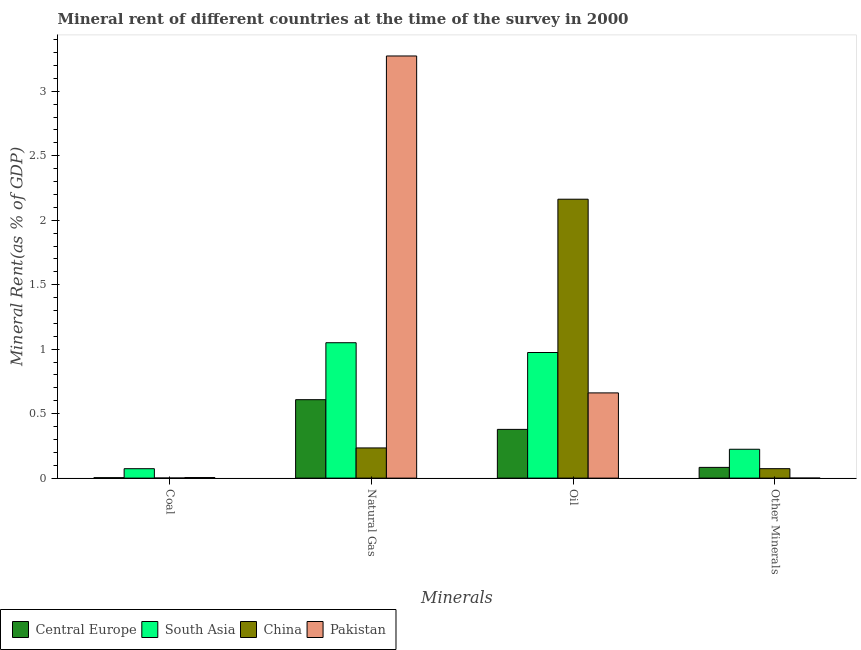How many different coloured bars are there?
Ensure brevity in your answer.  4. Are the number of bars on each tick of the X-axis equal?
Offer a very short reply. Yes. What is the label of the 4th group of bars from the left?
Give a very brief answer. Other Minerals. What is the natural gas rent in Pakistan?
Make the answer very short. 3.27. Across all countries, what is the maximum  rent of other minerals?
Keep it short and to the point. 0.22. Across all countries, what is the minimum coal rent?
Provide a succinct answer. 0. In which country was the natural gas rent maximum?
Your answer should be very brief. Pakistan. In which country was the  rent of other minerals minimum?
Provide a succinct answer. Pakistan. What is the total coal rent in the graph?
Provide a short and direct response. 0.08. What is the difference between the coal rent in China and that in Pakistan?
Ensure brevity in your answer.  -0. What is the difference between the oil rent in Central Europe and the natural gas rent in China?
Provide a succinct answer. 0.14. What is the average oil rent per country?
Provide a succinct answer. 1.04. What is the difference between the oil rent and  rent of other minerals in South Asia?
Offer a terse response. 0.75. What is the ratio of the oil rent in Pakistan to that in China?
Your response must be concise. 0.31. Is the difference between the coal rent in Central Europe and China greater than the difference between the oil rent in Central Europe and China?
Make the answer very short. Yes. What is the difference between the highest and the second highest  rent of other minerals?
Provide a short and direct response. 0.14. What is the difference between the highest and the lowest natural gas rent?
Ensure brevity in your answer.  3.04. Is it the case that in every country, the sum of the natural gas rent and coal rent is greater than the sum of oil rent and  rent of other minerals?
Your answer should be very brief. No. What does the 1st bar from the right in Coal represents?
Offer a very short reply. Pakistan. How many bars are there?
Ensure brevity in your answer.  16. Does the graph contain any zero values?
Provide a succinct answer. No. How many legend labels are there?
Offer a very short reply. 4. What is the title of the graph?
Provide a short and direct response. Mineral rent of different countries at the time of the survey in 2000. Does "Tajikistan" appear as one of the legend labels in the graph?
Ensure brevity in your answer.  No. What is the label or title of the X-axis?
Your answer should be compact. Minerals. What is the label or title of the Y-axis?
Keep it short and to the point. Mineral Rent(as % of GDP). What is the Mineral Rent(as % of GDP) in Central Europe in Coal?
Offer a very short reply. 0. What is the Mineral Rent(as % of GDP) of South Asia in Coal?
Provide a succinct answer. 0.07. What is the Mineral Rent(as % of GDP) in China in Coal?
Your answer should be compact. 0. What is the Mineral Rent(as % of GDP) of Pakistan in Coal?
Your answer should be compact. 0. What is the Mineral Rent(as % of GDP) in Central Europe in Natural Gas?
Offer a terse response. 0.61. What is the Mineral Rent(as % of GDP) of South Asia in Natural Gas?
Give a very brief answer. 1.05. What is the Mineral Rent(as % of GDP) in China in Natural Gas?
Your response must be concise. 0.23. What is the Mineral Rent(as % of GDP) of Pakistan in Natural Gas?
Make the answer very short. 3.27. What is the Mineral Rent(as % of GDP) of Central Europe in Oil?
Your response must be concise. 0.38. What is the Mineral Rent(as % of GDP) in South Asia in Oil?
Provide a short and direct response. 0.97. What is the Mineral Rent(as % of GDP) of China in Oil?
Ensure brevity in your answer.  2.16. What is the Mineral Rent(as % of GDP) in Pakistan in Oil?
Make the answer very short. 0.66. What is the Mineral Rent(as % of GDP) in Central Europe in Other Minerals?
Offer a very short reply. 0.08. What is the Mineral Rent(as % of GDP) in South Asia in Other Minerals?
Make the answer very short. 0.22. What is the Mineral Rent(as % of GDP) in China in Other Minerals?
Provide a succinct answer. 0.07. What is the Mineral Rent(as % of GDP) of Pakistan in Other Minerals?
Your answer should be very brief. 0. Across all Minerals, what is the maximum Mineral Rent(as % of GDP) in Central Europe?
Make the answer very short. 0.61. Across all Minerals, what is the maximum Mineral Rent(as % of GDP) in South Asia?
Your answer should be very brief. 1.05. Across all Minerals, what is the maximum Mineral Rent(as % of GDP) in China?
Keep it short and to the point. 2.16. Across all Minerals, what is the maximum Mineral Rent(as % of GDP) in Pakistan?
Offer a terse response. 3.27. Across all Minerals, what is the minimum Mineral Rent(as % of GDP) in Central Europe?
Offer a very short reply. 0. Across all Minerals, what is the minimum Mineral Rent(as % of GDP) of South Asia?
Keep it short and to the point. 0.07. Across all Minerals, what is the minimum Mineral Rent(as % of GDP) in China?
Your answer should be very brief. 0. Across all Minerals, what is the minimum Mineral Rent(as % of GDP) of Pakistan?
Offer a terse response. 0. What is the total Mineral Rent(as % of GDP) of Central Europe in the graph?
Make the answer very short. 1.07. What is the total Mineral Rent(as % of GDP) of South Asia in the graph?
Keep it short and to the point. 2.32. What is the total Mineral Rent(as % of GDP) in China in the graph?
Provide a succinct answer. 2.47. What is the total Mineral Rent(as % of GDP) in Pakistan in the graph?
Ensure brevity in your answer.  3.94. What is the difference between the Mineral Rent(as % of GDP) of Central Europe in Coal and that in Natural Gas?
Provide a short and direct response. -0.6. What is the difference between the Mineral Rent(as % of GDP) in South Asia in Coal and that in Natural Gas?
Ensure brevity in your answer.  -0.98. What is the difference between the Mineral Rent(as % of GDP) in China in Coal and that in Natural Gas?
Ensure brevity in your answer.  -0.23. What is the difference between the Mineral Rent(as % of GDP) in Pakistan in Coal and that in Natural Gas?
Keep it short and to the point. -3.27. What is the difference between the Mineral Rent(as % of GDP) of Central Europe in Coal and that in Oil?
Offer a very short reply. -0.37. What is the difference between the Mineral Rent(as % of GDP) of South Asia in Coal and that in Oil?
Give a very brief answer. -0.9. What is the difference between the Mineral Rent(as % of GDP) in China in Coal and that in Oil?
Provide a short and direct response. -2.16. What is the difference between the Mineral Rent(as % of GDP) in Pakistan in Coal and that in Oil?
Keep it short and to the point. -0.66. What is the difference between the Mineral Rent(as % of GDP) of Central Europe in Coal and that in Other Minerals?
Offer a very short reply. -0.08. What is the difference between the Mineral Rent(as % of GDP) in South Asia in Coal and that in Other Minerals?
Offer a very short reply. -0.15. What is the difference between the Mineral Rent(as % of GDP) in China in Coal and that in Other Minerals?
Offer a very short reply. -0.07. What is the difference between the Mineral Rent(as % of GDP) of Pakistan in Coal and that in Other Minerals?
Your answer should be very brief. 0. What is the difference between the Mineral Rent(as % of GDP) in Central Europe in Natural Gas and that in Oil?
Give a very brief answer. 0.23. What is the difference between the Mineral Rent(as % of GDP) in South Asia in Natural Gas and that in Oil?
Ensure brevity in your answer.  0.08. What is the difference between the Mineral Rent(as % of GDP) of China in Natural Gas and that in Oil?
Give a very brief answer. -1.93. What is the difference between the Mineral Rent(as % of GDP) in Pakistan in Natural Gas and that in Oil?
Provide a short and direct response. 2.61. What is the difference between the Mineral Rent(as % of GDP) of Central Europe in Natural Gas and that in Other Minerals?
Your response must be concise. 0.53. What is the difference between the Mineral Rent(as % of GDP) in South Asia in Natural Gas and that in Other Minerals?
Offer a terse response. 0.83. What is the difference between the Mineral Rent(as % of GDP) in China in Natural Gas and that in Other Minerals?
Your response must be concise. 0.16. What is the difference between the Mineral Rent(as % of GDP) of Pakistan in Natural Gas and that in Other Minerals?
Keep it short and to the point. 3.27. What is the difference between the Mineral Rent(as % of GDP) of Central Europe in Oil and that in Other Minerals?
Your answer should be compact. 0.29. What is the difference between the Mineral Rent(as % of GDP) in South Asia in Oil and that in Other Minerals?
Your response must be concise. 0.75. What is the difference between the Mineral Rent(as % of GDP) of China in Oil and that in Other Minerals?
Offer a terse response. 2.09. What is the difference between the Mineral Rent(as % of GDP) in Pakistan in Oil and that in Other Minerals?
Provide a short and direct response. 0.66. What is the difference between the Mineral Rent(as % of GDP) of Central Europe in Coal and the Mineral Rent(as % of GDP) of South Asia in Natural Gas?
Your answer should be compact. -1.05. What is the difference between the Mineral Rent(as % of GDP) of Central Europe in Coal and the Mineral Rent(as % of GDP) of China in Natural Gas?
Keep it short and to the point. -0.23. What is the difference between the Mineral Rent(as % of GDP) of Central Europe in Coal and the Mineral Rent(as % of GDP) of Pakistan in Natural Gas?
Your answer should be very brief. -3.27. What is the difference between the Mineral Rent(as % of GDP) in South Asia in Coal and the Mineral Rent(as % of GDP) in China in Natural Gas?
Offer a terse response. -0.16. What is the difference between the Mineral Rent(as % of GDP) of South Asia in Coal and the Mineral Rent(as % of GDP) of Pakistan in Natural Gas?
Provide a short and direct response. -3.2. What is the difference between the Mineral Rent(as % of GDP) of China in Coal and the Mineral Rent(as % of GDP) of Pakistan in Natural Gas?
Make the answer very short. -3.27. What is the difference between the Mineral Rent(as % of GDP) of Central Europe in Coal and the Mineral Rent(as % of GDP) of South Asia in Oil?
Your response must be concise. -0.97. What is the difference between the Mineral Rent(as % of GDP) in Central Europe in Coal and the Mineral Rent(as % of GDP) in China in Oil?
Your response must be concise. -2.16. What is the difference between the Mineral Rent(as % of GDP) in Central Europe in Coal and the Mineral Rent(as % of GDP) in Pakistan in Oil?
Keep it short and to the point. -0.66. What is the difference between the Mineral Rent(as % of GDP) of South Asia in Coal and the Mineral Rent(as % of GDP) of China in Oil?
Offer a terse response. -2.09. What is the difference between the Mineral Rent(as % of GDP) of South Asia in Coal and the Mineral Rent(as % of GDP) of Pakistan in Oil?
Your answer should be compact. -0.59. What is the difference between the Mineral Rent(as % of GDP) in China in Coal and the Mineral Rent(as % of GDP) in Pakistan in Oil?
Keep it short and to the point. -0.66. What is the difference between the Mineral Rent(as % of GDP) in Central Europe in Coal and the Mineral Rent(as % of GDP) in South Asia in Other Minerals?
Give a very brief answer. -0.22. What is the difference between the Mineral Rent(as % of GDP) of Central Europe in Coal and the Mineral Rent(as % of GDP) of China in Other Minerals?
Make the answer very short. -0.07. What is the difference between the Mineral Rent(as % of GDP) of Central Europe in Coal and the Mineral Rent(as % of GDP) of Pakistan in Other Minerals?
Offer a terse response. 0. What is the difference between the Mineral Rent(as % of GDP) of South Asia in Coal and the Mineral Rent(as % of GDP) of China in Other Minerals?
Your response must be concise. -0. What is the difference between the Mineral Rent(as % of GDP) in South Asia in Coal and the Mineral Rent(as % of GDP) in Pakistan in Other Minerals?
Your response must be concise. 0.07. What is the difference between the Mineral Rent(as % of GDP) of China in Coal and the Mineral Rent(as % of GDP) of Pakistan in Other Minerals?
Your response must be concise. 0. What is the difference between the Mineral Rent(as % of GDP) of Central Europe in Natural Gas and the Mineral Rent(as % of GDP) of South Asia in Oil?
Provide a succinct answer. -0.37. What is the difference between the Mineral Rent(as % of GDP) in Central Europe in Natural Gas and the Mineral Rent(as % of GDP) in China in Oil?
Your response must be concise. -1.55. What is the difference between the Mineral Rent(as % of GDP) of Central Europe in Natural Gas and the Mineral Rent(as % of GDP) of Pakistan in Oil?
Keep it short and to the point. -0.05. What is the difference between the Mineral Rent(as % of GDP) in South Asia in Natural Gas and the Mineral Rent(as % of GDP) in China in Oil?
Provide a short and direct response. -1.11. What is the difference between the Mineral Rent(as % of GDP) in South Asia in Natural Gas and the Mineral Rent(as % of GDP) in Pakistan in Oil?
Make the answer very short. 0.39. What is the difference between the Mineral Rent(as % of GDP) of China in Natural Gas and the Mineral Rent(as % of GDP) of Pakistan in Oil?
Your answer should be very brief. -0.43. What is the difference between the Mineral Rent(as % of GDP) in Central Europe in Natural Gas and the Mineral Rent(as % of GDP) in South Asia in Other Minerals?
Make the answer very short. 0.38. What is the difference between the Mineral Rent(as % of GDP) in Central Europe in Natural Gas and the Mineral Rent(as % of GDP) in China in Other Minerals?
Provide a short and direct response. 0.54. What is the difference between the Mineral Rent(as % of GDP) in Central Europe in Natural Gas and the Mineral Rent(as % of GDP) in Pakistan in Other Minerals?
Your answer should be very brief. 0.61. What is the difference between the Mineral Rent(as % of GDP) of South Asia in Natural Gas and the Mineral Rent(as % of GDP) of China in Other Minerals?
Your answer should be very brief. 0.98. What is the difference between the Mineral Rent(as % of GDP) of South Asia in Natural Gas and the Mineral Rent(as % of GDP) of Pakistan in Other Minerals?
Your answer should be very brief. 1.05. What is the difference between the Mineral Rent(as % of GDP) of China in Natural Gas and the Mineral Rent(as % of GDP) of Pakistan in Other Minerals?
Your answer should be very brief. 0.23. What is the difference between the Mineral Rent(as % of GDP) of Central Europe in Oil and the Mineral Rent(as % of GDP) of South Asia in Other Minerals?
Provide a succinct answer. 0.15. What is the difference between the Mineral Rent(as % of GDP) of Central Europe in Oil and the Mineral Rent(as % of GDP) of China in Other Minerals?
Make the answer very short. 0.3. What is the difference between the Mineral Rent(as % of GDP) in Central Europe in Oil and the Mineral Rent(as % of GDP) in Pakistan in Other Minerals?
Give a very brief answer. 0.38. What is the difference between the Mineral Rent(as % of GDP) of South Asia in Oil and the Mineral Rent(as % of GDP) of China in Other Minerals?
Offer a terse response. 0.9. What is the difference between the Mineral Rent(as % of GDP) in South Asia in Oil and the Mineral Rent(as % of GDP) in Pakistan in Other Minerals?
Provide a short and direct response. 0.97. What is the difference between the Mineral Rent(as % of GDP) of China in Oil and the Mineral Rent(as % of GDP) of Pakistan in Other Minerals?
Provide a short and direct response. 2.16. What is the average Mineral Rent(as % of GDP) in Central Europe per Minerals?
Offer a very short reply. 0.27. What is the average Mineral Rent(as % of GDP) of South Asia per Minerals?
Your response must be concise. 0.58. What is the average Mineral Rent(as % of GDP) in China per Minerals?
Ensure brevity in your answer.  0.62. What is the average Mineral Rent(as % of GDP) in Pakistan per Minerals?
Your answer should be compact. 0.98. What is the difference between the Mineral Rent(as % of GDP) in Central Europe and Mineral Rent(as % of GDP) in South Asia in Coal?
Make the answer very short. -0.07. What is the difference between the Mineral Rent(as % of GDP) of Central Europe and Mineral Rent(as % of GDP) of China in Coal?
Offer a terse response. 0. What is the difference between the Mineral Rent(as % of GDP) of Central Europe and Mineral Rent(as % of GDP) of Pakistan in Coal?
Keep it short and to the point. -0. What is the difference between the Mineral Rent(as % of GDP) in South Asia and Mineral Rent(as % of GDP) in China in Coal?
Provide a succinct answer. 0.07. What is the difference between the Mineral Rent(as % of GDP) of South Asia and Mineral Rent(as % of GDP) of Pakistan in Coal?
Your answer should be very brief. 0.07. What is the difference between the Mineral Rent(as % of GDP) of China and Mineral Rent(as % of GDP) of Pakistan in Coal?
Provide a short and direct response. -0. What is the difference between the Mineral Rent(as % of GDP) of Central Europe and Mineral Rent(as % of GDP) of South Asia in Natural Gas?
Provide a short and direct response. -0.44. What is the difference between the Mineral Rent(as % of GDP) in Central Europe and Mineral Rent(as % of GDP) in China in Natural Gas?
Your answer should be compact. 0.37. What is the difference between the Mineral Rent(as % of GDP) of Central Europe and Mineral Rent(as % of GDP) of Pakistan in Natural Gas?
Give a very brief answer. -2.67. What is the difference between the Mineral Rent(as % of GDP) in South Asia and Mineral Rent(as % of GDP) in China in Natural Gas?
Provide a succinct answer. 0.82. What is the difference between the Mineral Rent(as % of GDP) in South Asia and Mineral Rent(as % of GDP) in Pakistan in Natural Gas?
Your answer should be very brief. -2.22. What is the difference between the Mineral Rent(as % of GDP) of China and Mineral Rent(as % of GDP) of Pakistan in Natural Gas?
Provide a short and direct response. -3.04. What is the difference between the Mineral Rent(as % of GDP) in Central Europe and Mineral Rent(as % of GDP) in South Asia in Oil?
Ensure brevity in your answer.  -0.6. What is the difference between the Mineral Rent(as % of GDP) in Central Europe and Mineral Rent(as % of GDP) in China in Oil?
Make the answer very short. -1.78. What is the difference between the Mineral Rent(as % of GDP) of Central Europe and Mineral Rent(as % of GDP) of Pakistan in Oil?
Offer a very short reply. -0.28. What is the difference between the Mineral Rent(as % of GDP) in South Asia and Mineral Rent(as % of GDP) in China in Oil?
Make the answer very short. -1.19. What is the difference between the Mineral Rent(as % of GDP) of South Asia and Mineral Rent(as % of GDP) of Pakistan in Oil?
Offer a very short reply. 0.31. What is the difference between the Mineral Rent(as % of GDP) of China and Mineral Rent(as % of GDP) of Pakistan in Oil?
Your answer should be compact. 1.5. What is the difference between the Mineral Rent(as % of GDP) of Central Europe and Mineral Rent(as % of GDP) of South Asia in Other Minerals?
Your answer should be very brief. -0.14. What is the difference between the Mineral Rent(as % of GDP) in Central Europe and Mineral Rent(as % of GDP) in China in Other Minerals?
Provide a short and direct response. 0.01. What is the difference between the Mineral Rent(as % of GDP) in Central Europe and Mineral Rent(as % of GDP) in Pakistan in Other Minerals?
Offer a terse response. 0.08. What is the difference between the Mineral Rent(as % of GDP) of South Asia and Mineral Rent(as % of GDP) of China in Other Minerals?
Give a very brief answer. 0.15. What is the difference between the Mineral Rent(as % of GDP) of South Asia and Mineral Rent(as % of GDP) of Pakistan in Other Minerals?
Give a very brief answer. 0.22. What is the difference between the Mineral Rent(as % of GDP) in China and Mineral Rent(as % of GDP) in Pakistan in Other Minerals?
Give a very brief answer. 0.07. What is the ratio of the Mineral Rent(as % of GDP) of Central Europe in Coal to that in Natural Gas?
Your response must be concise. 0.01. What is the ratio of the Mineral Rent(as % of GDP) of South Asia in Coal to that in Natural Gas?
Your answer should be compact. 0.07. What is the ratio of the Mineral Rent(as % of GDP) of China in Coal to that in Natural Gas?
Your response must be concise. 0. What is the ratio of the Mineral Rent(as % of GDP) of Pakistan in Coal to that in Natural Gas?
Offer a terse response. 0. What is the ratio of the Mineral Rent(as % of GDP) in Central Europe in Coal to that in Oil?
Your answer should be very brief. 0.01. What is the ratio of the Mineral Rent(as % of GDP) in South Asia in Coal to that in Oil?
Provide a succinct answer. 0.07. What is the ratio of the Mineral Rent(as % of GDP) in China in Coal to that in Oil?
Provide a short and direct response. 0. What is the ratio of the Mineral Rent(as % of GDP) in Pakistan in Coal to that in Oil?
Keep it short and to the point. 0.01. What is the ratio of the Mineral Rent(as % of GDP) of Central Europe in Coal to that in Other Minerals?
Provide a short and direct response. 0.04. What is the ratio of the Mineral Rent(as % of GDP) of South Asia in Coal to that in Other Minerals?
Your answer should be compact. 0.33. What is the ratio of the Mineral Rent(as % of GDP) in China in Coal to that in Other Minerals?
Ensure brevity in your answer.  0.01. What is the ratio of the Mineral Rent(as % of GDP) in Pakistan in Coal to that in Other Minerals?
Your response must be concise. 27.02. What is the ratio of the Mineral Rent(as % of GDP) in Central Europe in Natural Gas to that in Oil?
Your response must be concise. 1.61. What is the ratio of the Mineral Rent(as % of GDP) of South Asia in Natural Gas to that in Oil?
Provide a succinct answer. 1.08. What is the ratio of the Mineral Rent(as % of GDP) of China in Natural Gas to that in Oil?
Your answer should be very brief. 0.11. What is the ratio of the Mineral Rent(as % of GDP) of Pakistan in Natural Gas to that in Oil?
Ensure brevity in your answer.  4.95. What is the ratio of the Mineral Rent(as % of GDP) in Central Europe in Natural Gas to that in Other Minerals?
Ensure brevity in your answer.  7.31. What is the ratio of the Mineral Rent(as % of GDP) in South Asia in Natural Gas to that in Other Minerals?
Give a very brief answer. 4.69. What is the ratio of the Mineral Rent(as % of GDP) of China in Natural Gas to that in Other Minerals?
Provide a succinct answer. 3.2. What is the ratio of the Mineral Rent(as % of GDP) of Pakistan in Natural Gas to that in Other Minerals?
Give a very brief answer. 1.98e+04. What is the ratio of the Mineral Rent(as % of GDP) of Central Europe in Oil to that in Other Minerals?
Your answer should be very brief. 4.54. What is the ratio of the Mineral Rent(as % of GDP) of South Asia in Oil to that in Other Minerals?
Provide a short and direct response. 4.35. What is the ratio of the Mineral Rent(as % of GDP) of China in Oil to that in Other Minerals?
Make the answer very short. 29.52. What is the ratio of the Mineral Rent(as % of GDP) of Pakistan in Oil to that in Other Minerals?
Your response must be concise. 3990.51. What is the difference between the highest and the second highest Mineral Rent(as % of GDP) in Central Europe?
Provide a short and direct response. 0.23. What is the difference between the highest and the second highest Mineral Rent(as % of GDP) of South Asia?
Offer a terse response. 0.08. What is the difference between the highest and the second highest Mineral Rent(as % of GDP) in China?
Keep it short and to the point. 1.93. What is the difference between the highest and the second highest Mineral Rent(as % of GDP) in Pakistan?
Provide a succinct answer. 2.61. What is the difference between the highest and the lowest Mineral Rent(as % of GDP) of Central Europe?
Offer a very short reply. 0.6. What is the difference between the highest and the lowest Mineral Rent(as % of GDP) of South Asia?
Your response must be concise. 0.98. What is the difference between the highest and the lowest Mineral Rent(as % of GDP) of China?
Ensure brevity in your answer.  2.16. What is the difference between the highest and the lowest Mineral Rent(as % of GDP) of Pakistan?
Your response must be concise. 3.27. 